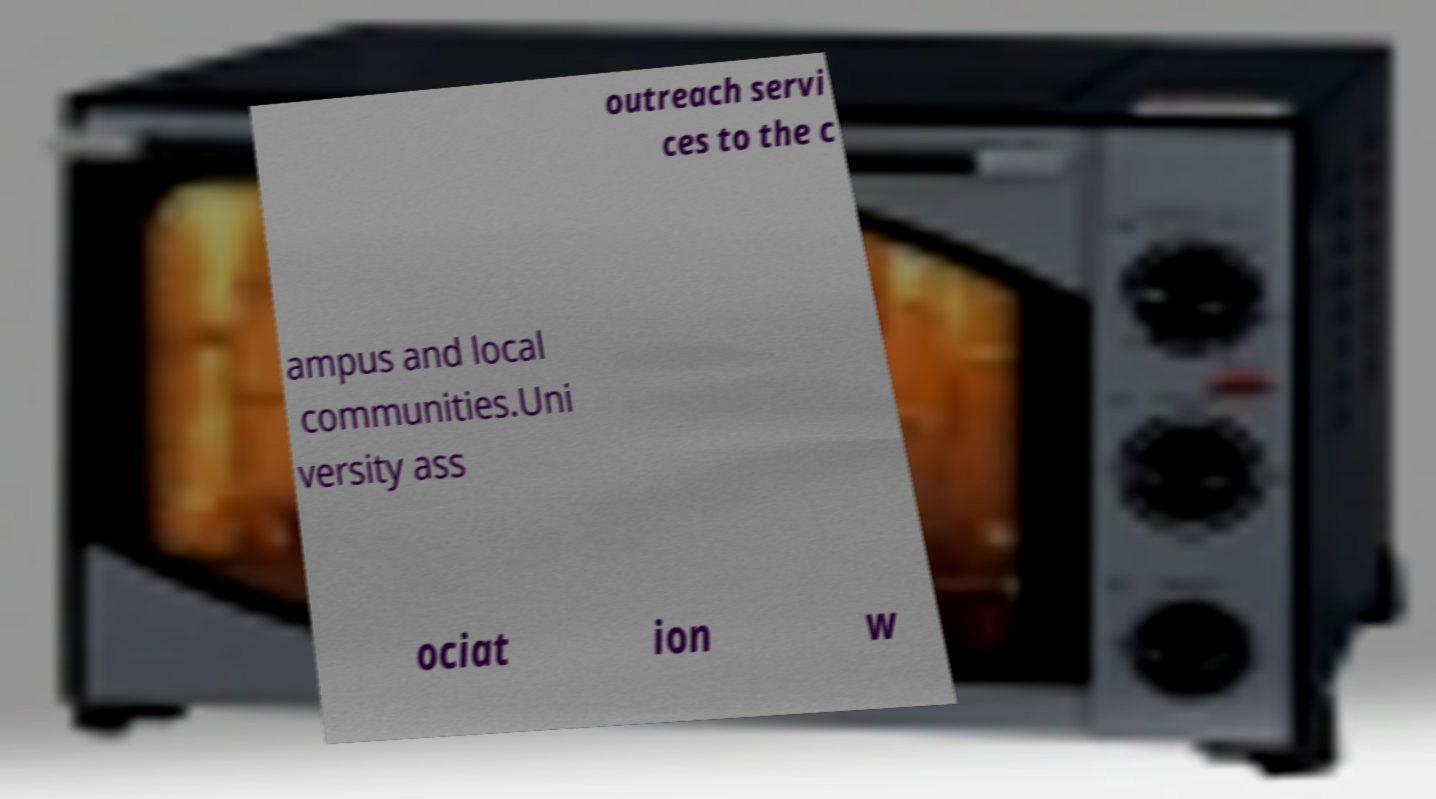What messages or text are displayed in this image? I need them in a readable, typed format. outreach servi ces to the c ampus and local communities.Uni versity ass ociat ion w 